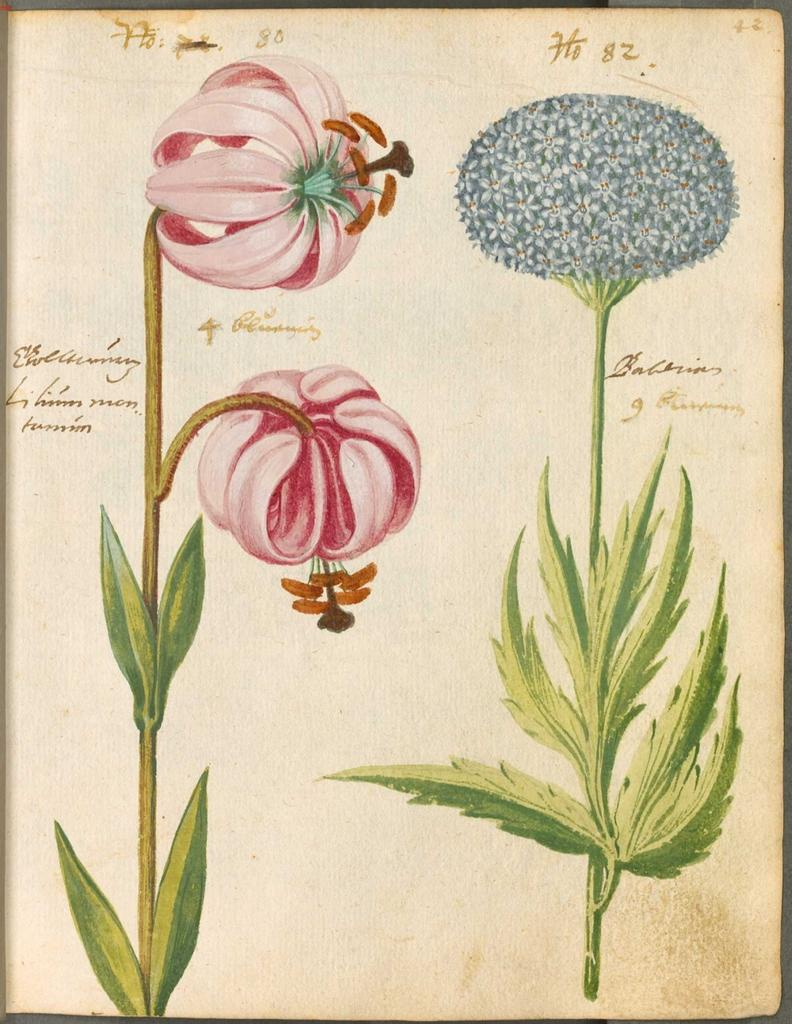What is the main subject of the image? The main subject of the image is a depiction of plants and flowers on a paper. What else can be seen on the paper? There is writing on the paper. What type of house is shown in the image? There is no house present in the image; it features a depiction of plants and flowers on a paper with writing. What kind of blade can be seen cutting through the plants in the image? There is no blade present in the image; it only contains a depiction of plants and flowers on a paper with writing. 